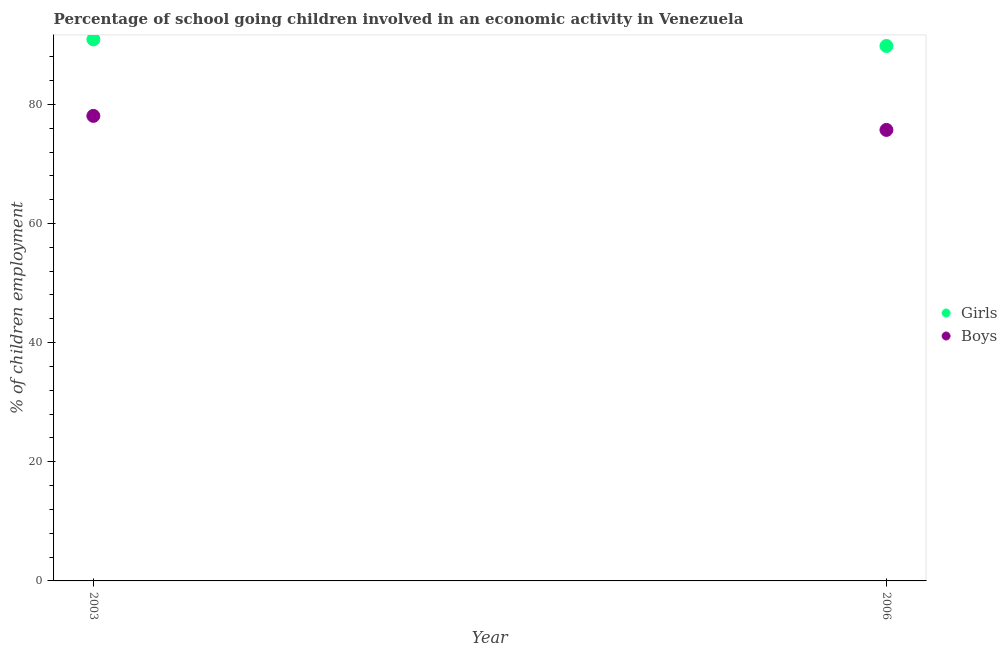How many different coloured dotlines are there?
Offer a very short reply. 2. Is the number of dotlines equal to the number of legend labels?
Keep it short and to the point. Yes. What is the percentage of school going boys in 2006?
Give a very brief answer. 75.71. Across all years, what is the maximum percentage of school going girls?
Provide a succinct answer. 90.91. Across all years, what is the minimum percentage of school going boys?
Make the answer very short. 75.71. In which year was the percentage of school going boys maximum?
Provide a short and direct response. 2003. In which year was the percentage of school going boys minimum?
Offer a very short reply. 2006. What is the total percentage of school going girls in the graph?
Provide a short and direct response. 180.72. What is the difference between the percentage of school going girls in 2003 and that in 2006?
Offer a terse response. 1.1. What is the difference between the percentage of school going boys in 2003 and the percentage of school going girls in 2006?
Your answer should be very brief. -11.74. What is the average percentage of school going girls per year?
Your answer should be compact. 90.36. In the year 2006, what is the difference between the percentage of school going boys and percentage of school going girls?
Your answer should be very brief. -14.09. In how many years, is the percentage of school going girls greater than 32 %?
Make the answer very short. 2. What is the ratio of the percentage of school going girls in 2003 to that in 2006?
Provide a succinct answer. 1.01. In how many years, is the percentage of school going boys greater than the average percentage of school going boys taken over all years?
Make the answer very short. 1. Is the percentage of school going boys strictly greater than the percentage of school going girls over the years?
Offer a terse response. No. Are the values on the major ticks of Y-axis written in scientific E-notation?
Your answer should be compact. No. Does the graph contain any zero values?
Make the answer very short. No. What is the title of the graph?
Offer a very short reply. Percentage of school going children involved in an economic activity in Venezuela. Does "Nitrous oxide emissions" appear as one of the legend labels in the graph?
Keep it short and to the point. No. What is the label or title of the Y-axis?
Your answer should be very brief. % of children employment. What is the % of children employment in Girls in 2003?
Keep it short and to the point. 90.91. What is the % of children employment in Boys in 2003?
Your answer should be very brief. 78.07. What is the % of children employment in Girls in 2006?
Provide a succinct answer. 89.81. What is the % of children employment of Boys in 2006?
Offer a very short reply. 75.71. Across all years, what is the maximum % of children employment in Girls?
Give a very brief answer. 90.91. Across all years, what is the maximum % of children employment of Boys?
Provide a short and direct response. 78.07. Across all years, what is the minimum % of children employment in Girls?
Keep it short and to the point. 89.81. Across all years, what is the minimum % of children employment in Boys?
Your answer should be compact. 75.71. What is the total % of children employment in Girls in the graph?
Ensure brevity in your answer.  180.72. What is the total % of children employment of Boys in the graph?
Ensure brevity in your answer.  153.78. What is the difference between the % of children employment of Girls in 2003 and that in 2006?
Provide a succinct answer. 1.1. What is the difference between the % of children employment in Boys in 2003 and that in 2006?
Give a very brief answer. 2.36. What is the difference between the % of children employment of Girls in 2003 and the % of children employment of Boys in 2006?
Your response must be concise. 15.2. What is the average % of children employment in Girls per year?
Offer a terse response. 90.36. What is the average % of children employment of Boys per year?
Keep it short and to the point. 76.89. In the year 2003, what is the difference between the % of children employment in Girls and % of children employment in Boys?
Your answer should be compact. 12.84. In the year 2006, what is the difference between the % of children employment of Girls and % of children employment of Boys?
Keep it short and to the point. 14.09. What is the ratio of the % of children employment of Girls in 2003 to that in 2006?
Provide a short and direct response. 1.01. What is the ratio of the % of children employment in Boys in 2003 to that in 2006?
Make the answer very short. 1.03. What is the difference between the highest and the second highest % of children employment of Girls?
Provide a short and direct response. 1.1. What is the difference between the highest and the second highest % of children employment of Boys?
Provide a short and direct response. 2.36. What is the difference between the highest and the lowest % of children employment in Girls?
Keep it short and to the point. 1.1. What is the difference between the highest and the lowest % of children employment of Boys?
Provide a succinct answer. 2.36. 